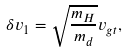<formula> <loc_0><loc_0><loc_500><loc_500>\delta v _ { 1 } = \sqrt { \frac { m _ { H } } { m _ { d } } } v _ { g t } ,</formula> 